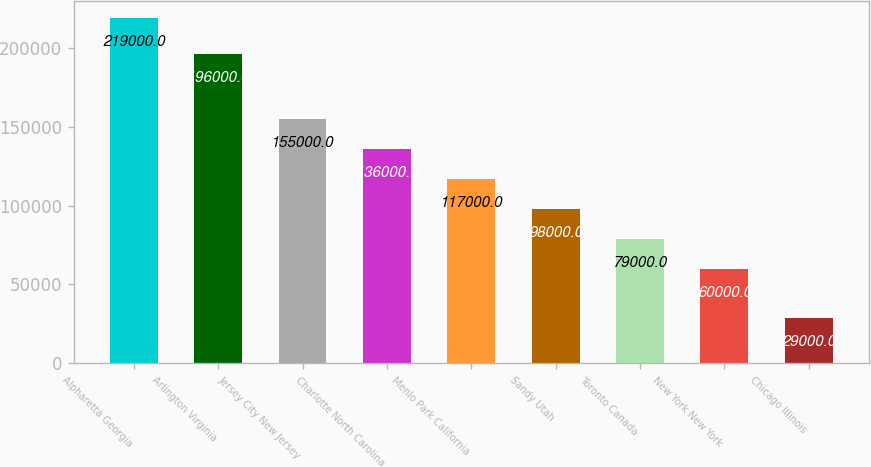<chart> <loc_0><loc_0><loc_500><loc_500><bar_chart><fcel>Alpharetta Georgia<fcel>Arlington Virginia<fcel>Jersey City New Jersey<fcel>Charlotte North Carolina<fcel>Menlo Park California<fcel>Sandy Utah<fcel>Toronto Canada<fcel>New York New York<fcel>Chicago Illinois<nl><fcel>219000<fcel>196000<fcel>155000<fcel>136000<fcel>117000<fcel>98000<fcel>79000<fcel>60000<fcel>29000<nl></chart> 